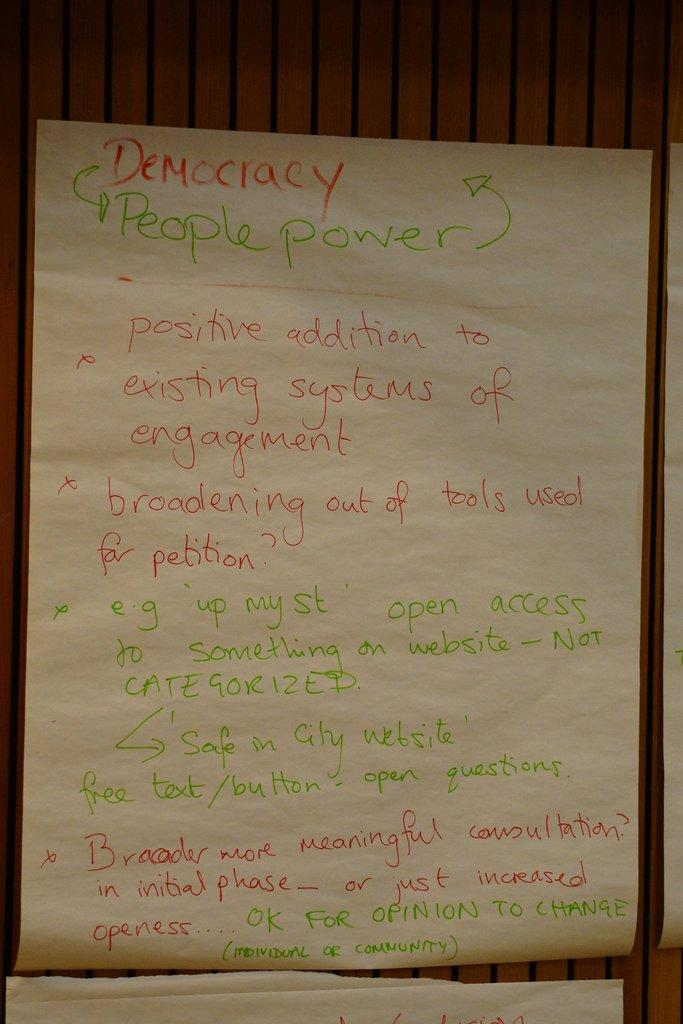<image>
Relay a brief, clear account of the picture shown. A list about democracy has items written in red and green. 